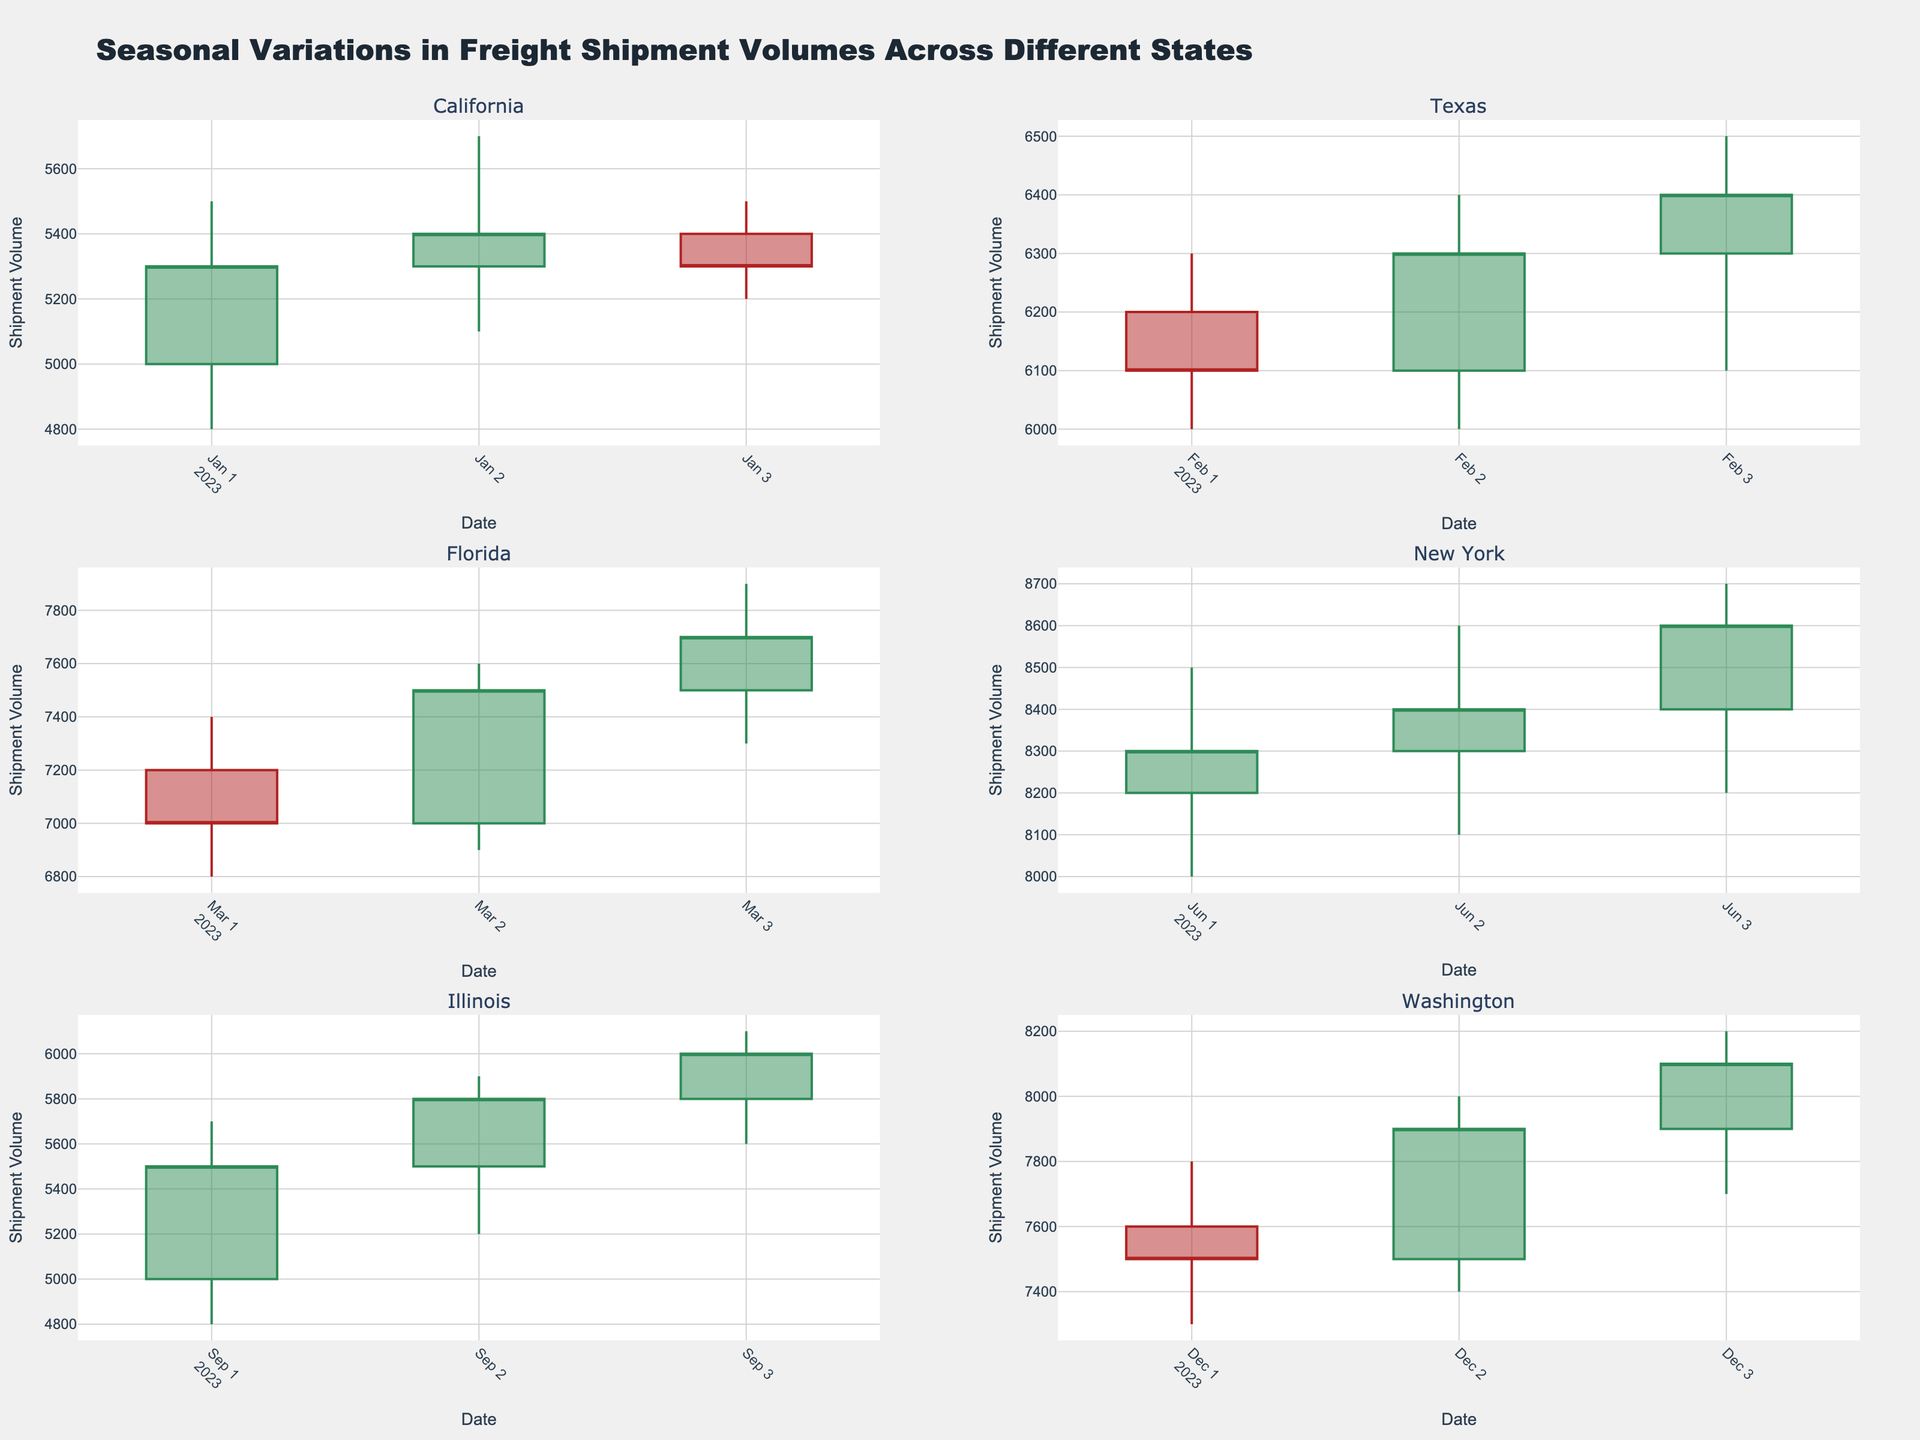What is the total number of states shown in the figure? The figure displays candlestick plots for each unique state present in the dataset. To determine the number of states, count the number of subplots or the unique state names in the title/subplot labels.
Answer: 6 What is the general trend in shipment volumes for California in January? Observing the candlestick plots for California in January, we see that the closing prices have a slight upward trend from the beginning and end dates, indicating an overall increase in shipment volumes.
Answer: Increasing Which state has the highest closing shipment volume, and what is that value? To identify the state with the highest closing shipment volume, look at the highest 'Close' value across all candlestick plots. The Florida subplot in March shows a closing volume of 7700 which is the highest among the states.
Answer: Florida, 7700 How does the shipment volume in Texas in February compare to that in New York in June? For Texas in February, examine the closing volume values: 6100, 6300, and 6400. For New York in June, the closing values are 8300, 8400, and 8600. New York's shipment volumes are consistently higher in comparison to Texas’s values.
Answer: New York is higher Which state shows the largest variation in shipment volumes in a single month? To find out which state shows the largest variation, compare the difference between the high and low values in a single month’s subplot. Florida in March shows highs around 7900 and lows around 6800, resulting in a variation of 1200, which is the largest.
Answer: Florida What month was associated with the lowest shipment volume in Illinois? In the Illinois subplot for September, look at the 'Low' values. On September 1st, the low is 4800, which is the lowest among all the given dates for Illinois.
Answer: September 1st How does the trend in Florida compare to Washington in regards to shipment volumes? In Florida (March), observe an upward trend in closing volumes from 7000 to 7700. Likewise, in Washington (December), the trend is also upward, starting from 7500 and increasing to 8100. Both states exhibit an increasing trend in shipment volumes.
Answer: Both are increasing During which month did New York experience the most consistent shipment volume? For consistency analysis, look at the difference between high and low values across dates. In June for New York, the high-low differences are relatively small compared to other states, indicating consistent shipment volumes—June 1st (8500-8000), June 2nd (8600-8100), June 3rd (8700-8200).
Answer: June Which state experienced a significant drop in shipment volume over a specific period? In the subplot for California in January, note that shipment volumes drop from 5400 to 5300 between January 2nd and January 3rd. The decrease is observed in the candlestick characteristics: 5700 to 5500 high and 5100 to 5200 low.
Answer: California 